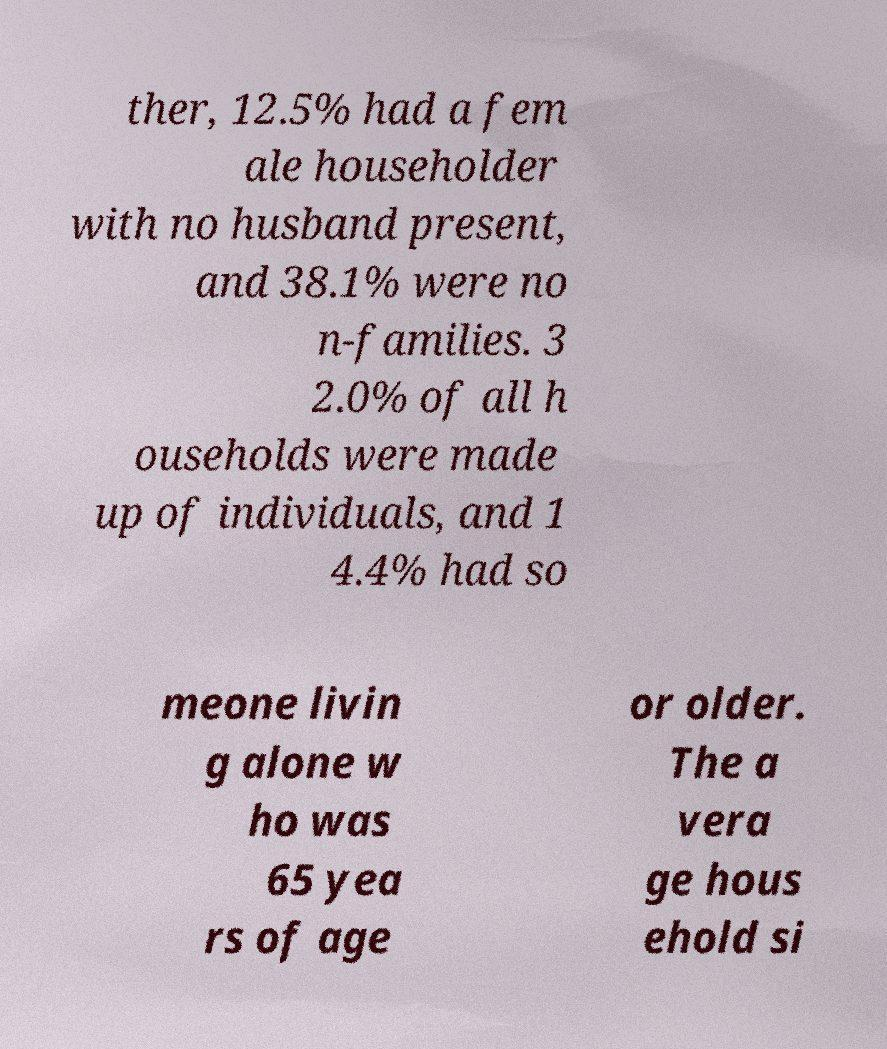There's text embedded in this image that I need extracted. Can you transcribe it verbatim? ther, 12.5% had a fem ale householder with no husband present, and 38.1% were no n-families. 3 2.0% of all h ouseholds were made up of individuals, and 1 4.4% had so meone livin g alone w ho was 65 yea rs of age or older. The a vera ge hous ehold si 